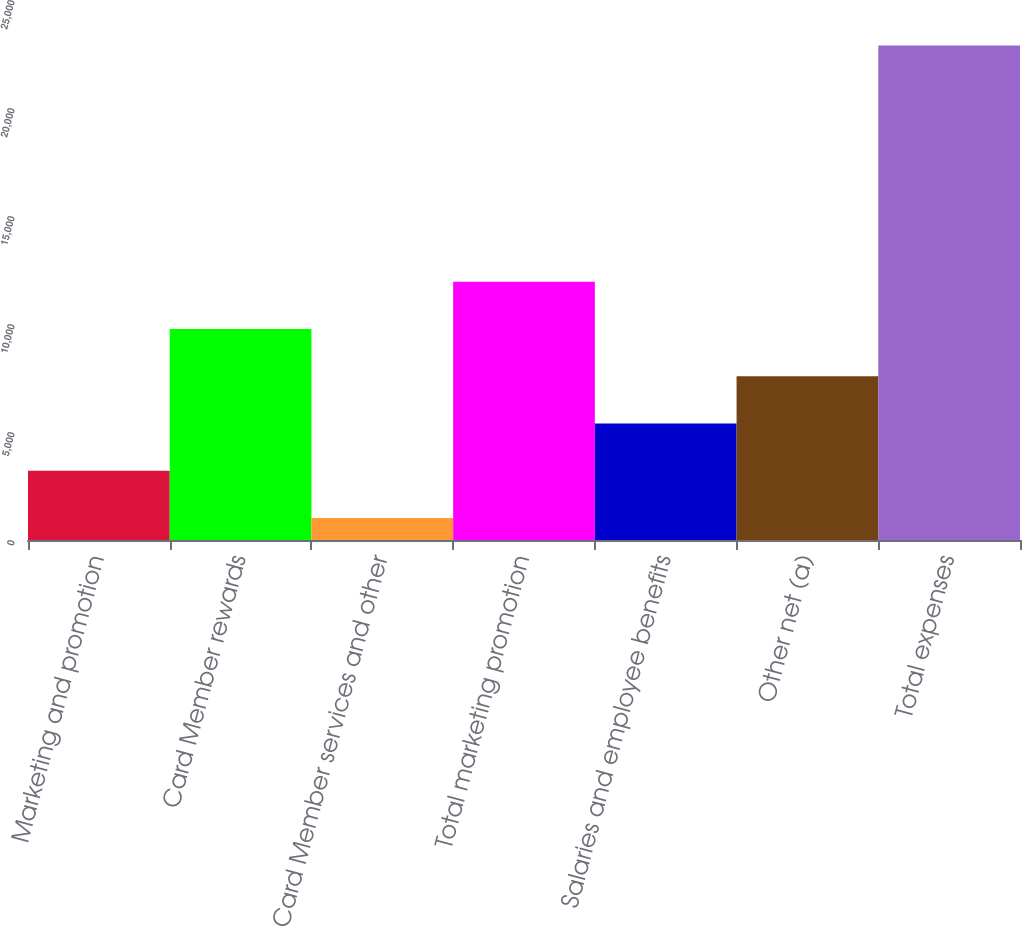<chart> <loc_0><loc_0><loc_500><loc_500><bar_chart><fcel>Marketing and promotion<fcel>Card Member rewards<fcel>Card Member services and other<fcel>Total marketing promotion<fcel>Salaries and employee benefits<fcel>Other net (a)<fcel>Total expenses<nl><fcel>3205.4<fcel>9767.6<fcel>1018<fcel>11955<fcel>5392.8<fcel>7580.2<fcel>22892<nl></chart> 